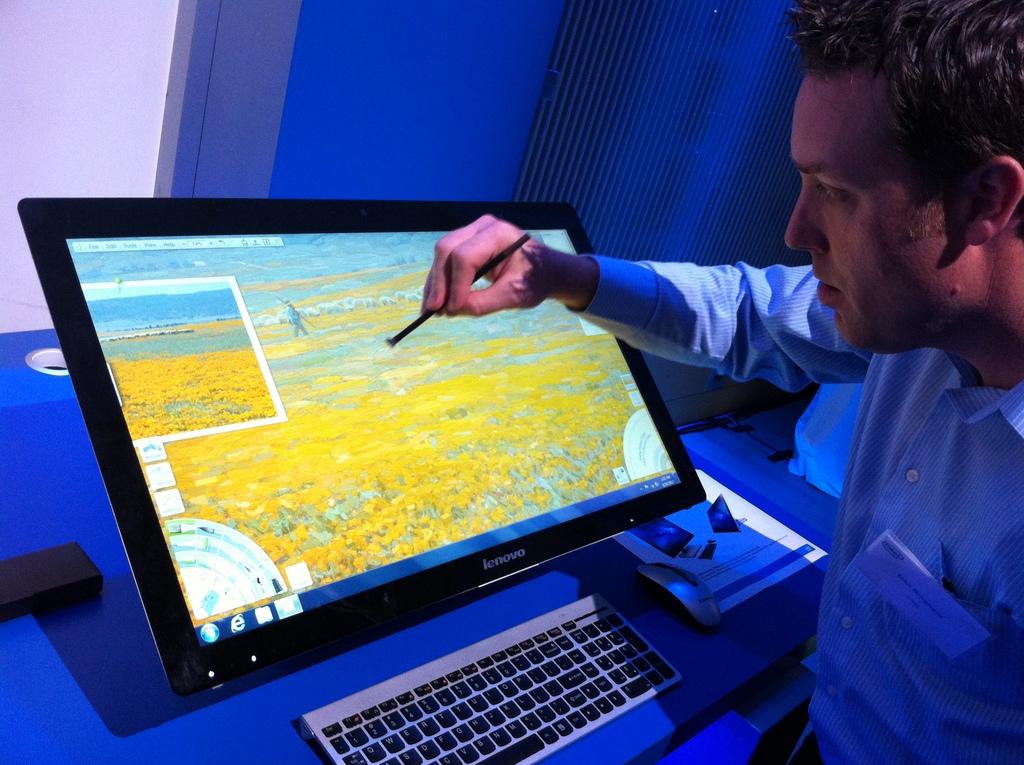What's the make of the screen?
Your answer should be very brief. Lenovo. 